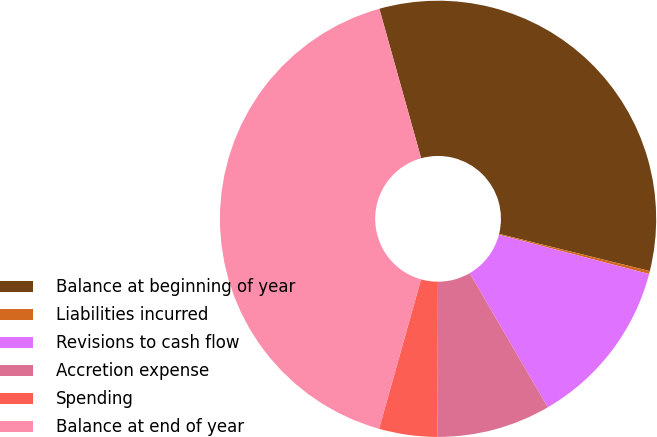<chart> <loc_0><loc_0><loc_500><loc_500><pie_chart><fcel>Balance at beginning of year<fcel>Liabilities incurred<fcel>Revisions to cash flow<fcel>Accretion expense<fcel>Spending<fcel>Balance at end of year<nl><fcel>33.19%<fcel>0.22%<fcel>12.54%<fcel>8.43%<fcel>4.32%<fcel>41.3%<nl></chart> 